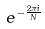<formula> <loc_0><loc_0><loc_500><loc_500>e ^ { - \frac { 2 \pi i } { N } }</formula> 